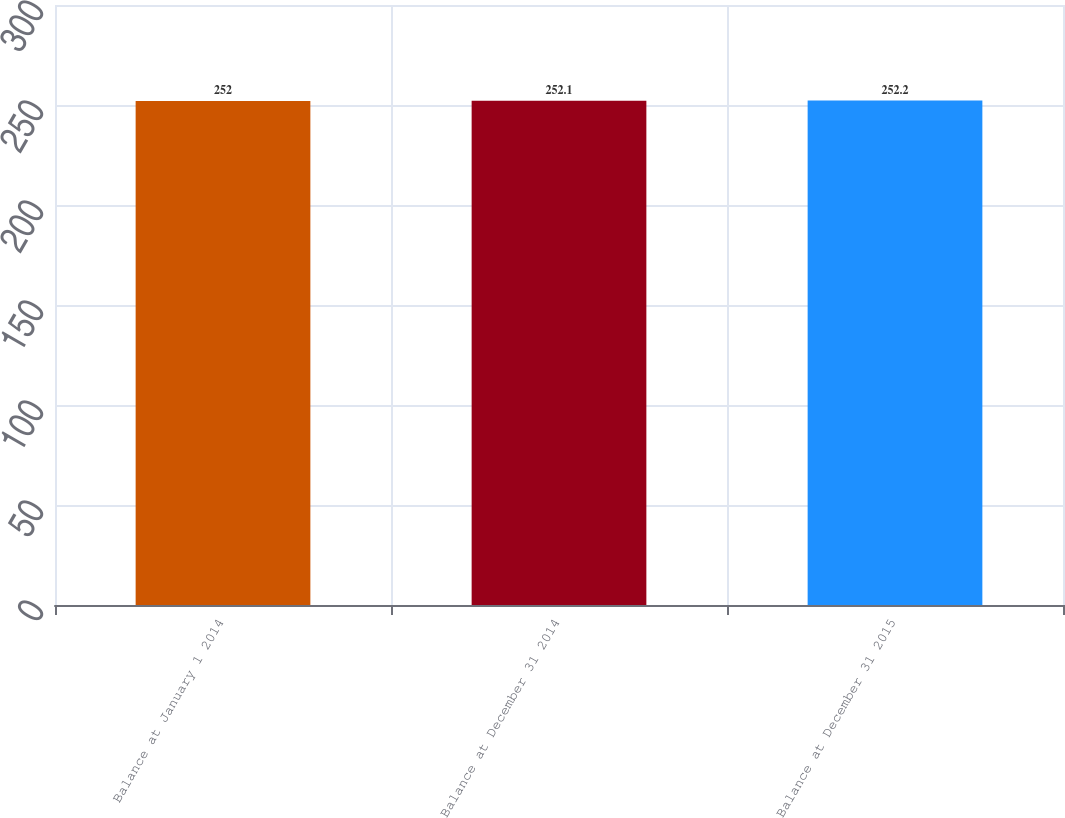Convert chart. <chart><loc_0><loc_0><loc_500><loc_500><bar_chart><fcel>Balance at January 1 2014<fcel>Balance at December 31 2014<fcel>Balance at December 31 2015<nl><fcel>252<fcel>252.1<fcel>252.2<nl></chart> 